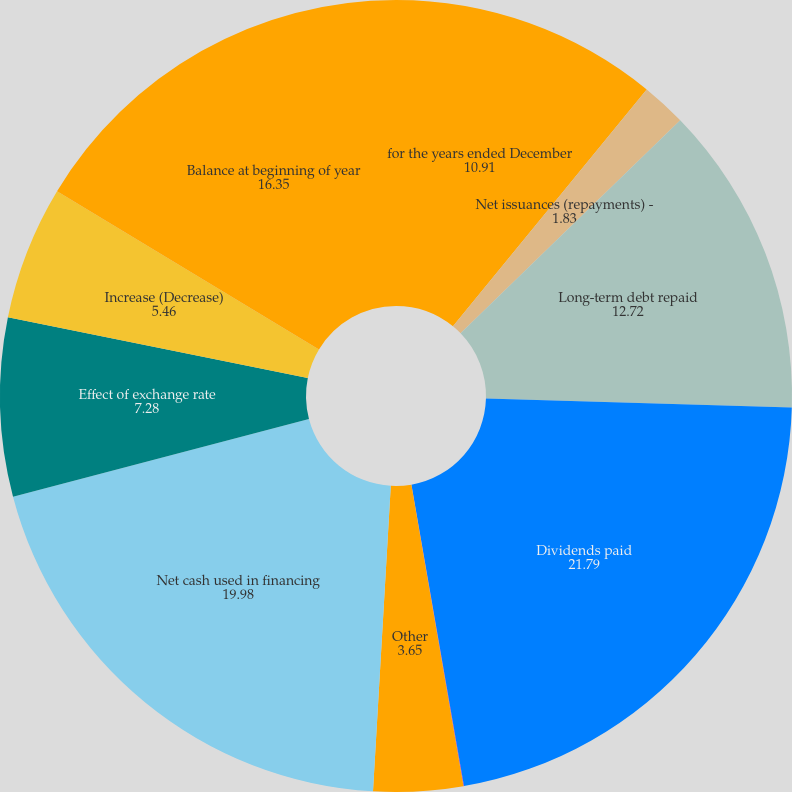<chart> <loc_0><loc_0><loc_500><loc_500><pie_chart><fcel>for the years ended December<fcel>Net issuances (repayments) -<fcel>Long-term debt repaid<fcel>Dividends paid<fcel>Sale (purchase) of subsidiary<fcel>Other<fcel>Net cash used in financing<fcel>Effect of exchange rate<fcel>Increase (Decrease)<fcel>Balance at beginning of year<nl><fcel>10.91%<fcel>1.83%<fcel>12.72%<fcel>21.79%<fcel>0.02%<fcel>3.65%<fcel>19.98%<fcel>7.28%<fcel>5.46%<fcel>16.35%<nl></chart> 